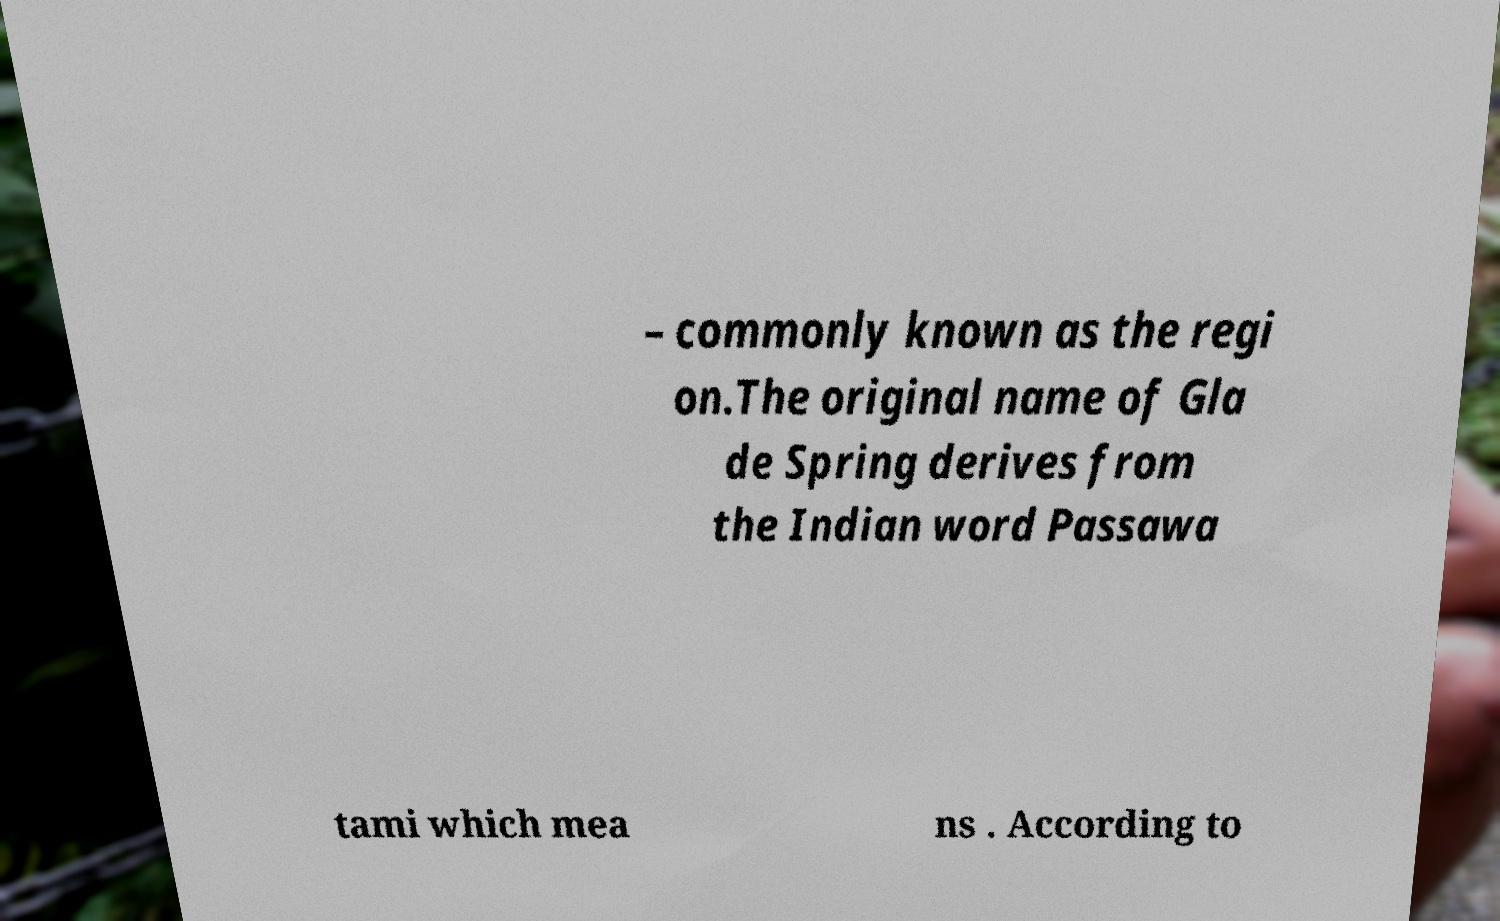Please read and relay the text visible in this image. What does it say? – commonly known as the regi on.The original name of Gla de Spring derives from the Indian word Passawa tami which mea ns . According to 